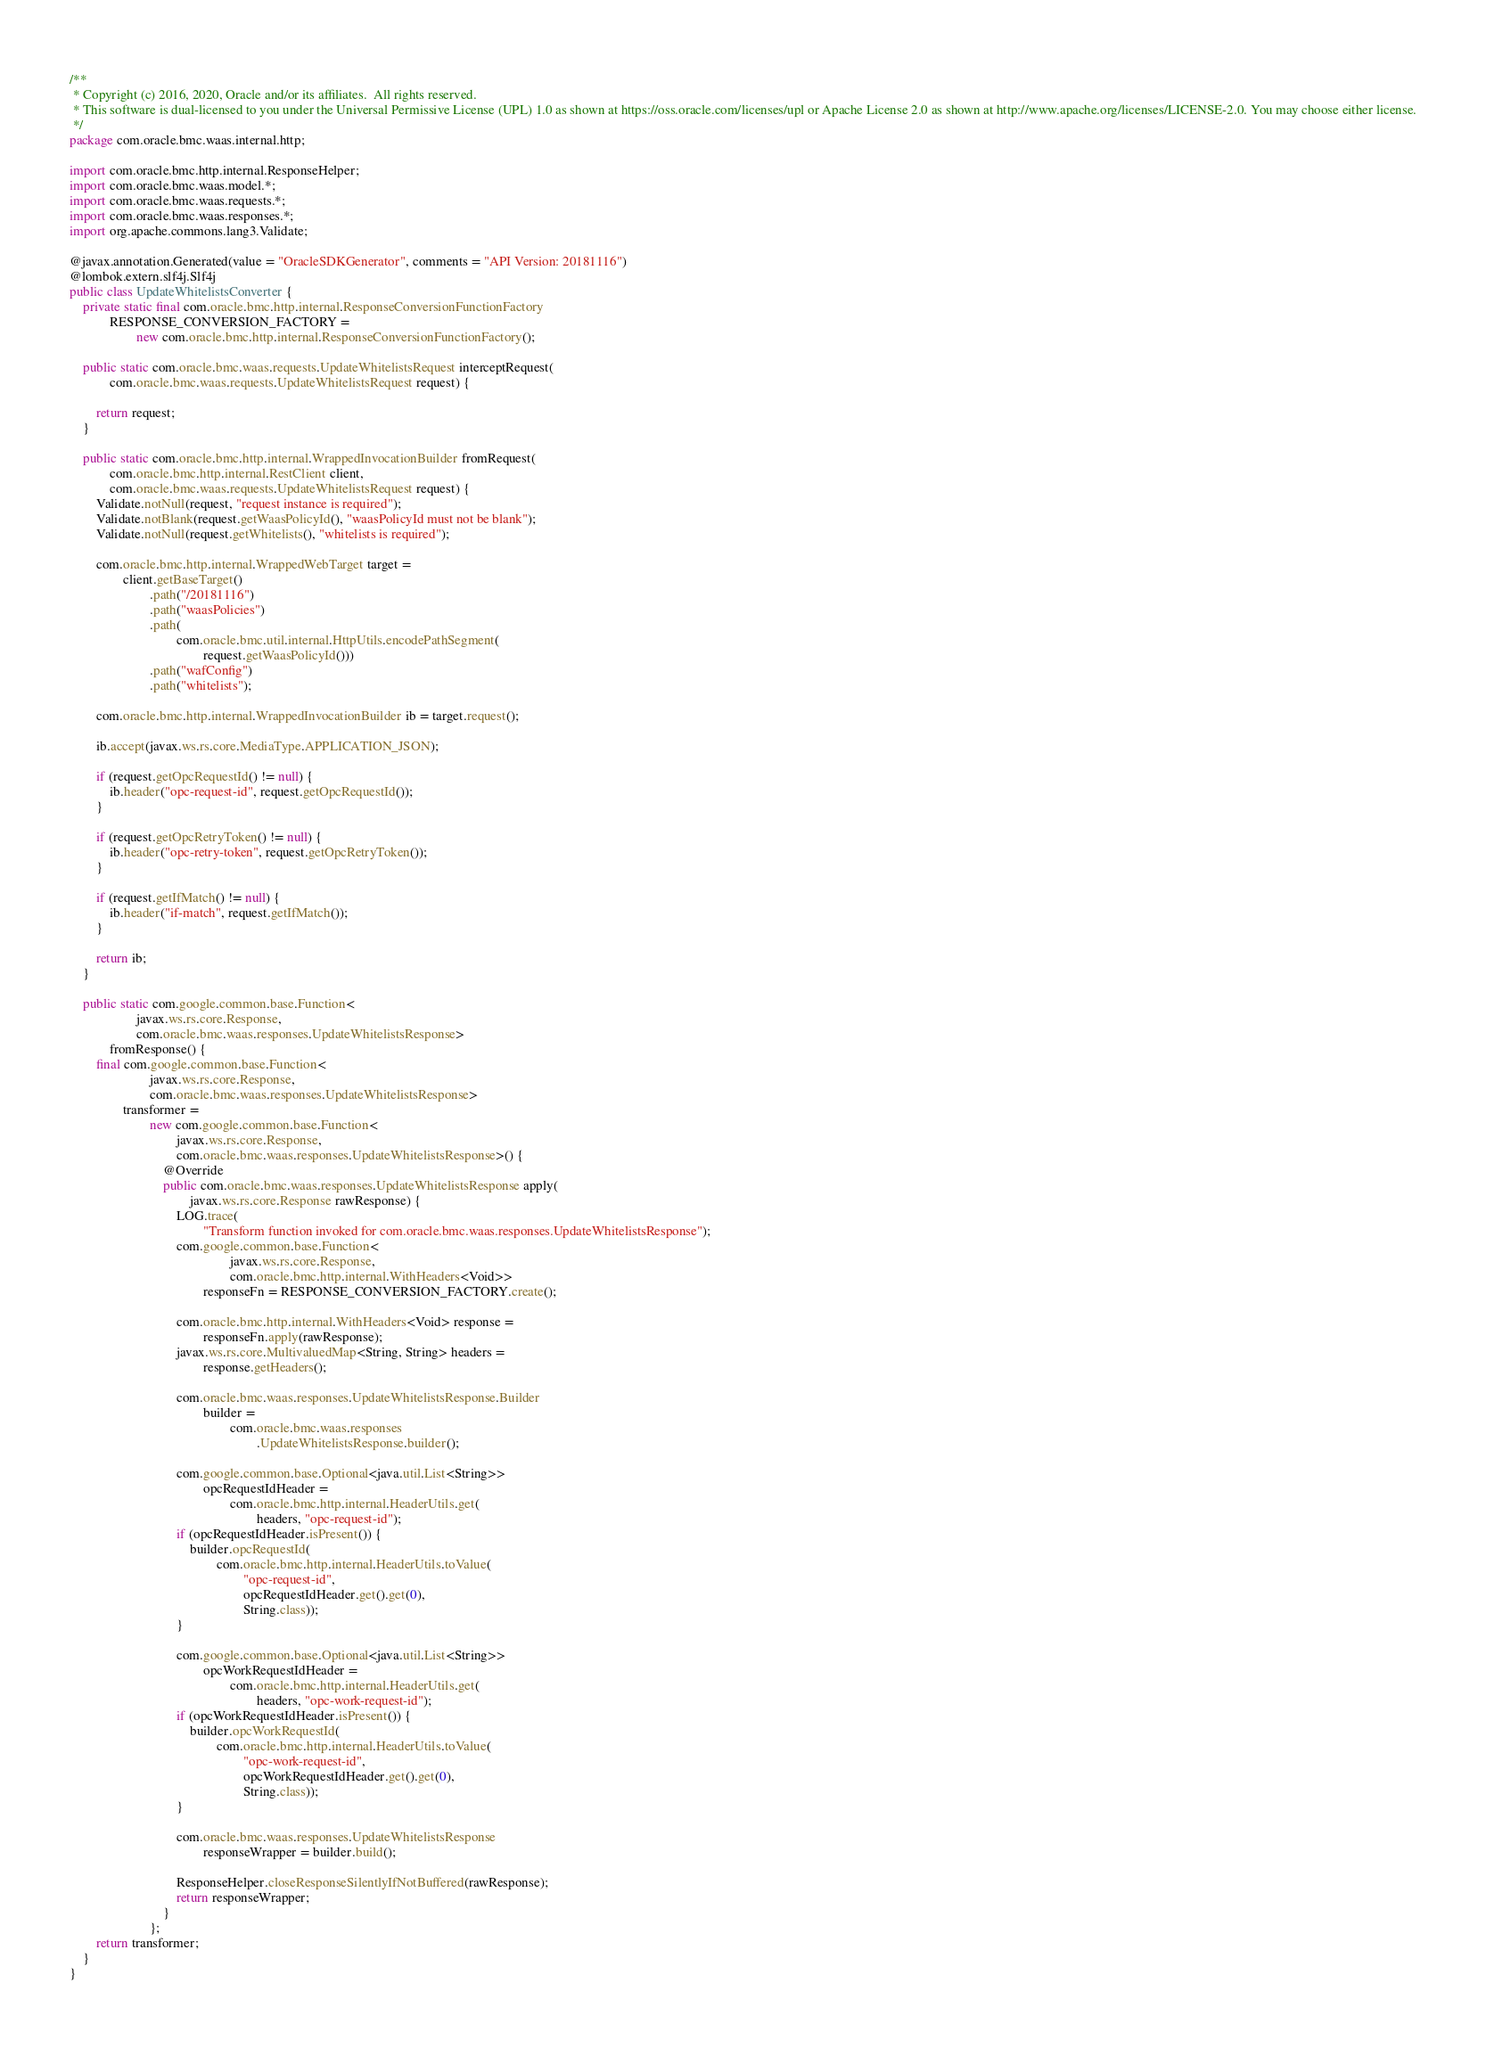<code> <loc_0><loc_0><loc_500><loc_500><_Java_>/**
 * Copyright (c) 2016, 2020, Oracle and/or its affiliates.  All rights reserved.
 * This software is dual-licensed to you under the Universal Permissive License (UPL) 1.0 as shown at https://oss.oracle.com/licenses/upl or Apache License 2.0 as shown at http://www.apache.org/licenses/LICENSE-2.0. You may choose either license.
 */
package com.oracle.bmc.waas.internal.http;

import com.oracle.bmc.http.internal.ResponseHelper;
import com.oracle.bmc.waas.model.*;
import com.oracle.bmc.waas.requests.*;
import com.oracle.bmc.waas.responses.*;
import org.apache.commons.lang3.Validate;

@javax.annotation.Generated(value = "OracleSDKGenerator", comments = "API Version: 20181116")
@lombok.extern.slf4j.Slf4j
public class UpdateWhitelistsConverter {
    private static final com.oracle.bmc.http.internal.ResponseConversionFunctionFactory
            RESPONSE_CONVERSION_FACTORY =
                    new com.oracle.bmc.http.internal.ResponseConversionFunctionFactory();

    public static com.oracle.bmc.waas.requests.UpdateWhitelistsRequest interceptRequest(
            com.oracle.bmc.waas.requests.UpdateWhitelistsRequest request) {

        return request;
    }

    public static com.oracle.bmc.http.internal.WrappedInvocationBuilder fromRequest(
            com.oracle.bmc.http.internal.RestClient client,
            com.oracle.bmc.waas.requests.UpdateWhitelistsRequest request) {
        Validate.notNull(request, "request instance is required");
        Validate.notBlank(request.getWaasPolicyId(), "waasPolicyId must not be blank");
        Validate.notNull(request.getWhitelists(), "whitelists is required");

        com.oracle.bmc.http.internal.WrappedWebTarget target =
                client.getBaseTarget()
                        .path("/20181116")
                        .path("waasPolicies")
                        .path(
                                com.oracle.bmc.util.internal.HttpUtils.encodePathSegment(
                                        request.getWaasPolicyId()))
                        .path("wafConfig")
                        .path("whitelists");

        com.oracle.bmc.http.internal.WrappedInvocationBuilder ib = target.request();

        ib.accept(javax.ws.rs.core.MediaType.APPLICATION_JSON);

        if (request.getOpcRequestId() != null) {
            ib.header("opc-request-id", request.getOpcRequestId());
        }

        if (request.getOpcRetryToken() != null) {
            ib.header("opc-retry-token", request.getOpcRetryToken());
        }

        if (request.getIfMatch() != null) {
            ib.header("if-match", request.getIfMatch());
        }

        return ib;
    }

    public static com.google.common.base.Function<
                    javax.ws.rs.core.Response,
                    com.oracle.bmc.waas.responses.UpdateWhitelistsResponse>
            fromResponse() {
        final com.google.common.base.Function<
                        javax.ws.rs.core.Response,
                        com.oracle.bmc.waas.responses.UpdateWhitelistsResponse>
                transformer =
                        new com.google.common.base.Function<
                                javax.ws.rs.core.Response,
                                com.oracle.bmc.waas.responses.UpdateWhitelistsResponse>() {
                            @Override
                            public com.oracle.bmc.waas.responses.UpdateWhitelistsResponse apply(
                                    javax.ws.rs.core.Response rawResponse) {
                                LOG.trace(
                                        "Transform function invoked for com.oracle.bmc.waas.responses.UpdateWhitelistsResponse");
                                com.google.common.base.Function<
                                                javax.ws.rs.core.Response,
                                                com.oracle.bmc.http.internal.WithHeaders<Void>>
                                        responseFn = RESPONSE_CONVERSION_FACTORY.create();

                                com.oracle.bmc.http.internal.WithHeaders<Void> response =
                                        responseFn.apply(rawResponse);
                                javax.ws.rs.core.MultivaluedMap<String, String> headers =
                                        response.getHeaders();

                                com.oracle.bmc.waas.responses.UpdateWhitelistsResponse.Builder
                                        builder =
                                                com.oracle.bmc.waas.responses
                                                        .UpdateWhitelistsResponse.builder();

                                com.google.common.base.Optional<java.util.List<String>>
                                        opcRequestIdHeader =
                                                com.oracle.bmc.http.internal.HeaderUtils.get(
                                                        headers, "opc-request-id");
                                if (opcRequestIdHeader.isPresent()) {
                                    builder.opcRequestId(
                                            com.oracle.bmc.http.internal.HeaderUtils.toValue(
                                                    "opc-request-id",
                                                    opcRequestIdHeader.get().get(0),
                                                    String.class));
                                }

                                com.google.common.base.Optional<java.util.List<String>>
                                        opcWorkRequestIdHeader =
                                                com.oracle.bmc.http.internal.HeaderUtils.get(
                                                        headers, "opc-work-request-id");
                                if (opcWorkRequestIdHeader.isPresent()) {
                                    builder.opcWorkRequestId(
                                            com.oracle.bmc.http.internal.HeaderUtils.toValue(
                                                    "opc-work-request-id",
                                                    opcWorkRequestIdHeader.get().get(0),
                                                    String.class));
                                }

                                com.oracle.bmc.waas.responses.UpdateWhitelistsResponse
                                        responseWrapper = builder.build();

                                ResponseHelper.closeResponseSilentlyIfNotBuffered(rawResponse);
                                return responseWrapper;
                            }
                        };
        return transformer;
    }
}
</code> 